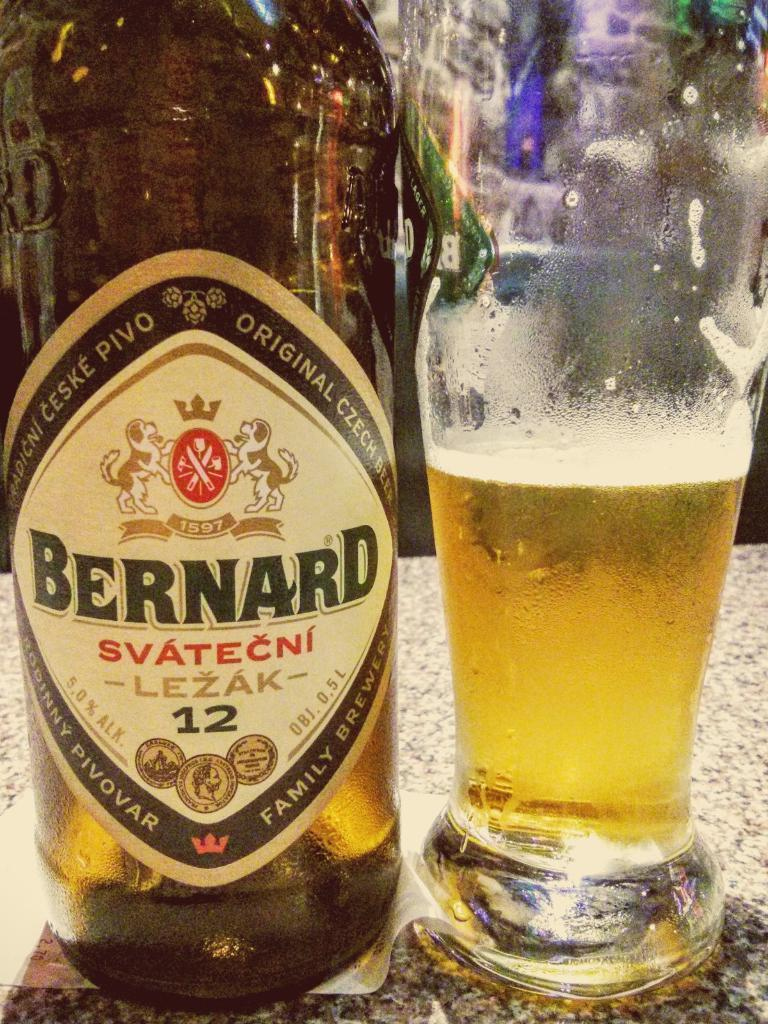<image>
Relay a brief, clear account of the picture shown. a bottle that has the word Bernard on it 